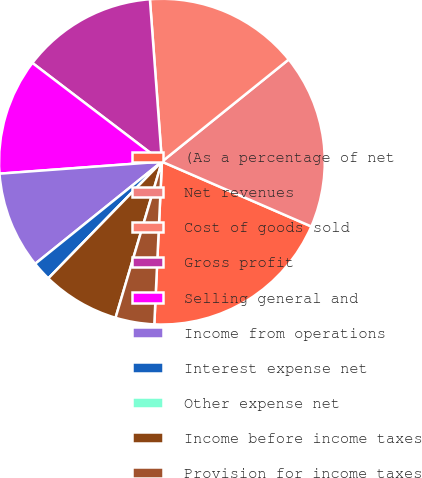Convert chart. <chart><loc_0><loc_0><loc_500><loc_500><pie_chart><fcel>(As a percentage of net<fcel>Net revenues<fcel>Cost of goods sold<fcel>Gross profit<fcel>Selling general and<fcel>Income from operations<fcel>Interest expense net<fcel>Other expense net<fcel>Income before income taxes<fcel>Provision for income taxes<nl><fcel>19.23%<fcel>17.31%<fcel>15.38%<fcel>13.46%<fcel>11.54%<fcel>9.62%<fcel>1.92%<fcel>0.0%<fcel>7.69%<fcel>3.85%<nl></chart> 